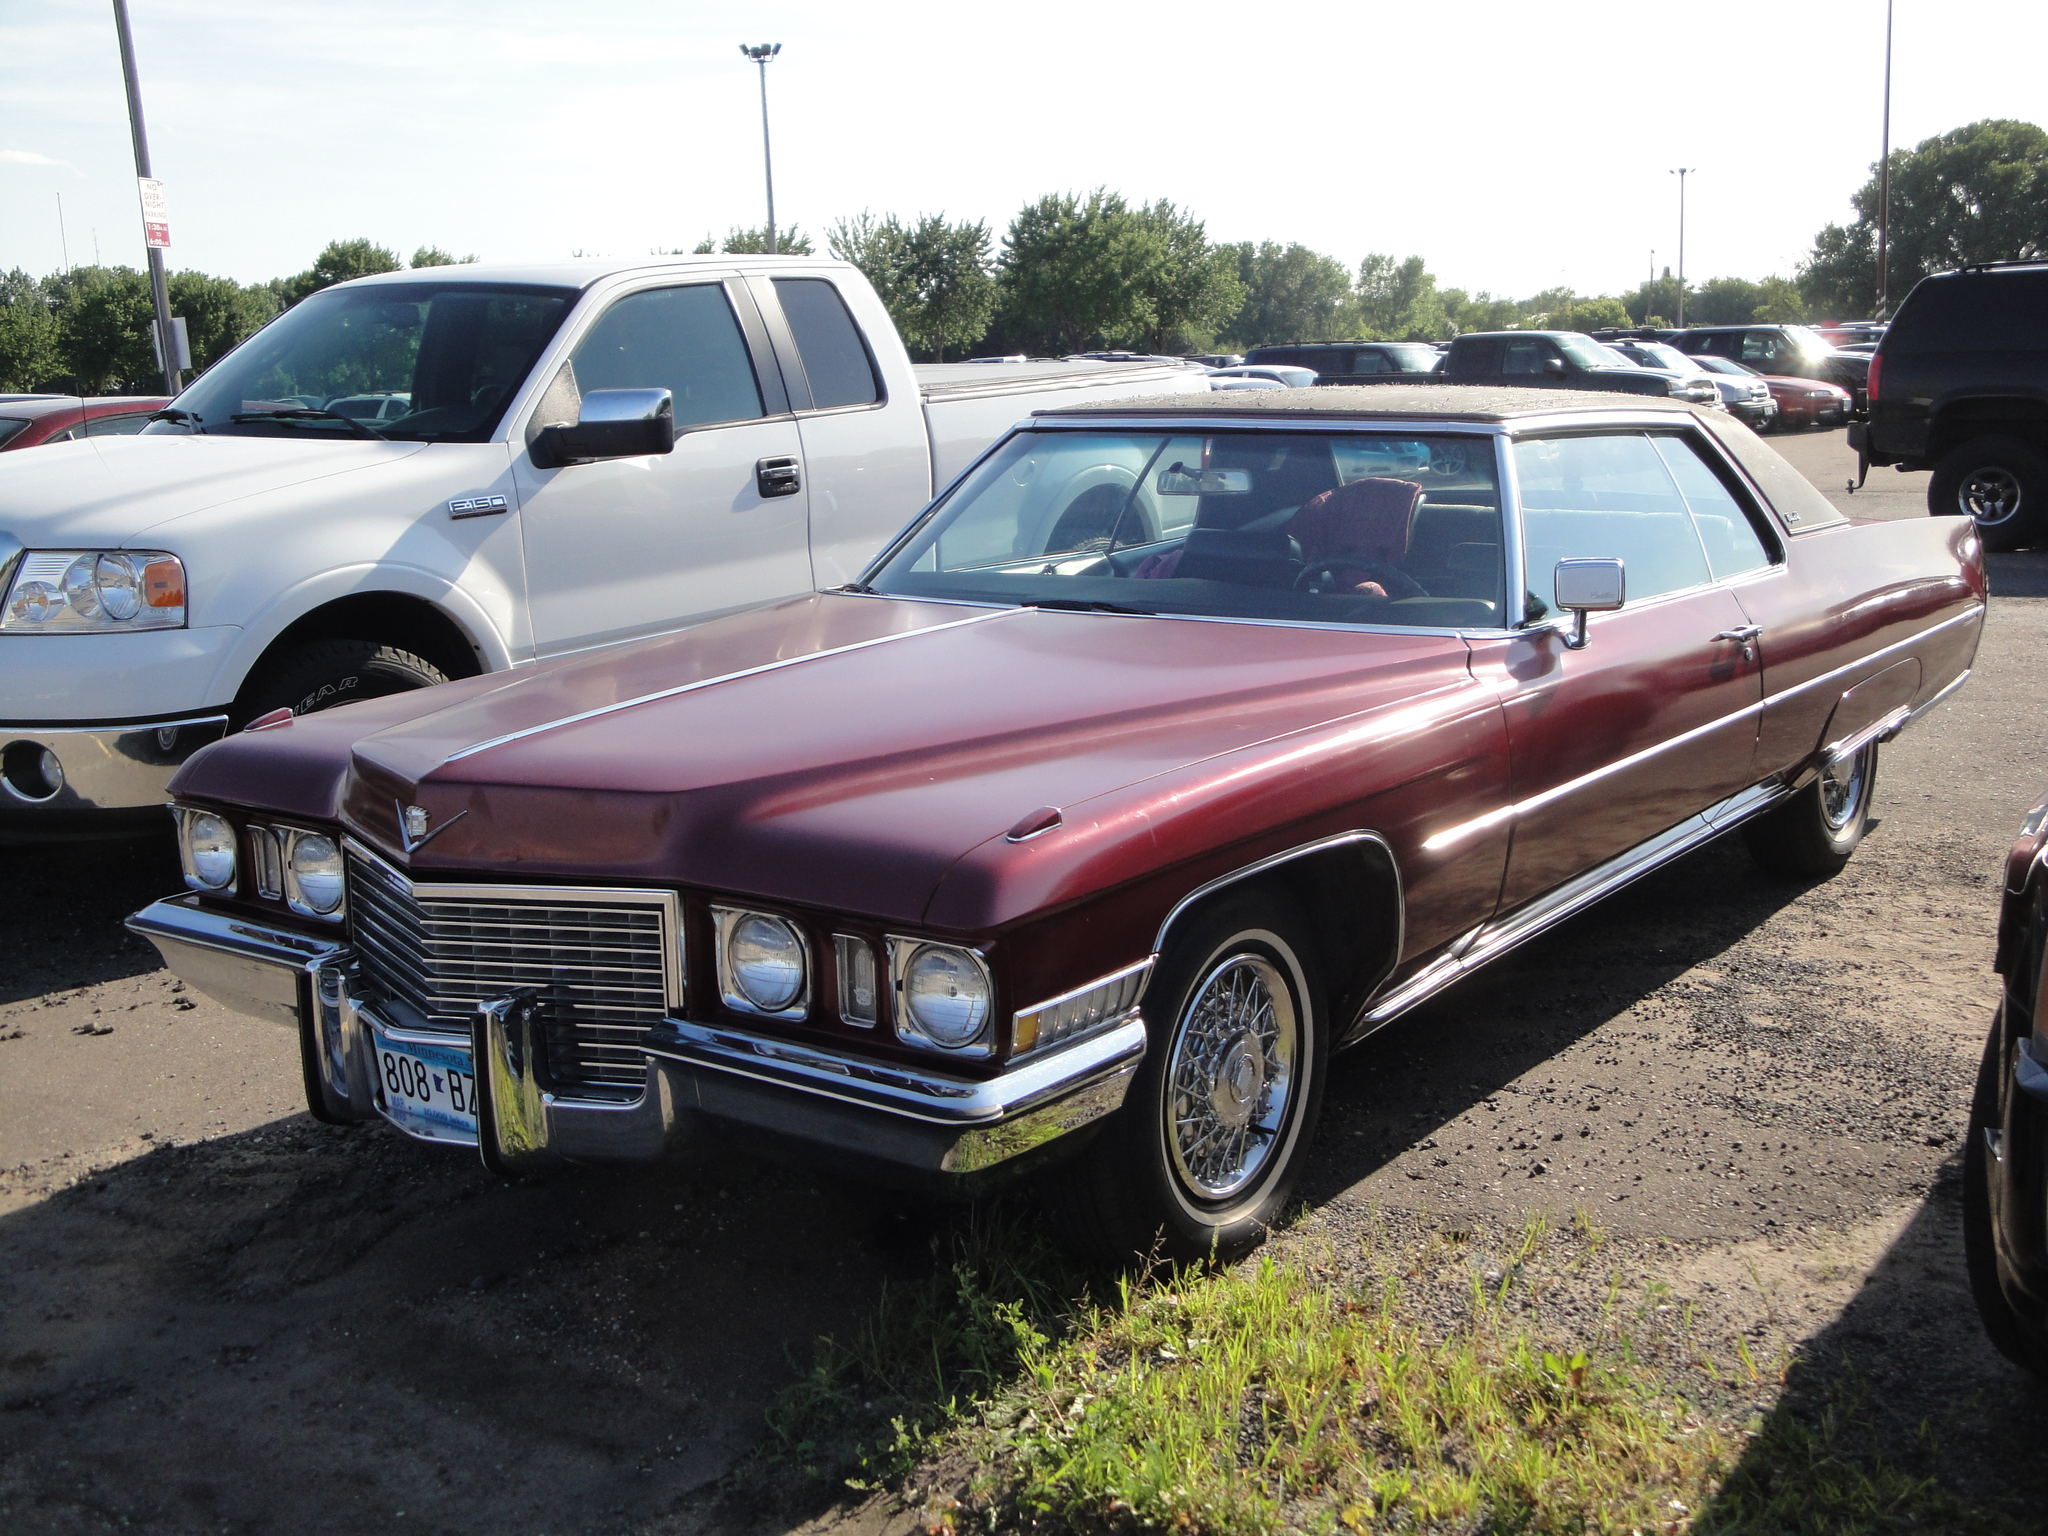Could you give a brief overview of what you see in this image? In this image we can see a group of cars which are placed on the ground. We can also see some stones, grass, poles, boards, a group of trees and the sky which looks cloudy. 